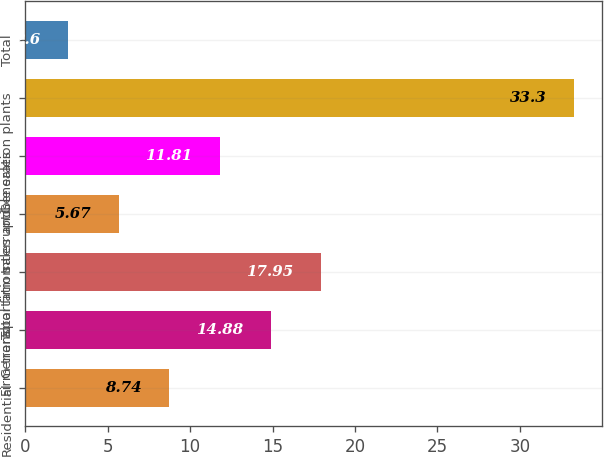Convert chart. <chart><loc_0><loc_0><loc_500><loc_500><bar_chart><fcel>Residential<fcel>General<fcel>Firm transportation<fcel>Total firm sales and<fcel>Interruptible sales<fcel>Generation plants<fcel>Total<nl><fcel>8.74<fcel>14.88<fcel>17.95<fcel>5.67<fcel>11.81<fcel>33.3<fcel>2.6<nl></chart> 